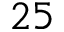<formula> <loc_0><loc_0><loc_500><loc_500>2 5</formula> 